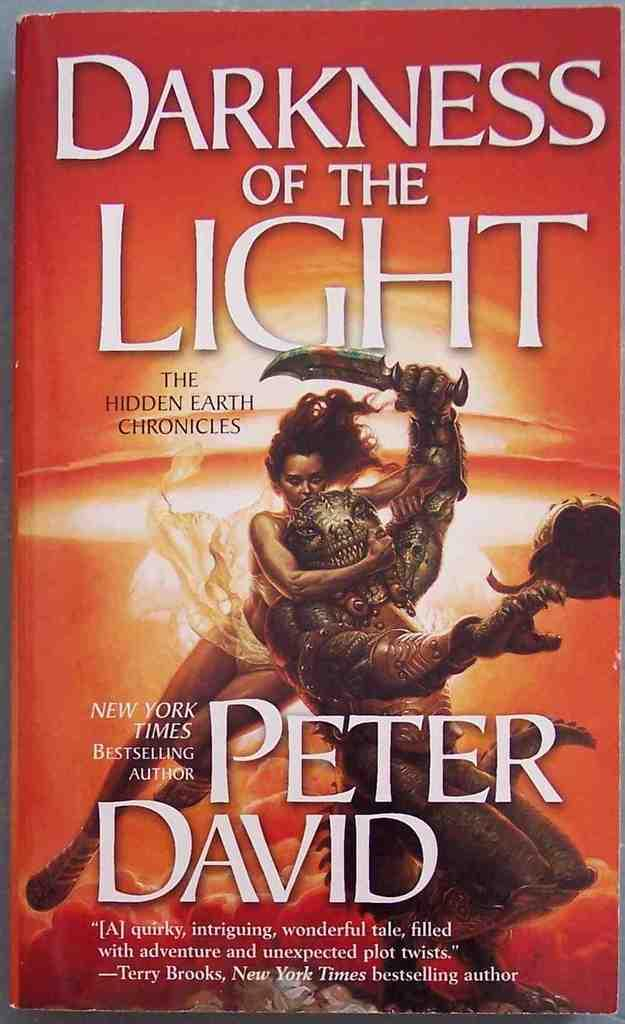<image>
Create a compact narrative representing the image presented. A book by bestselling author Peter David titled Darkness of the Light. 